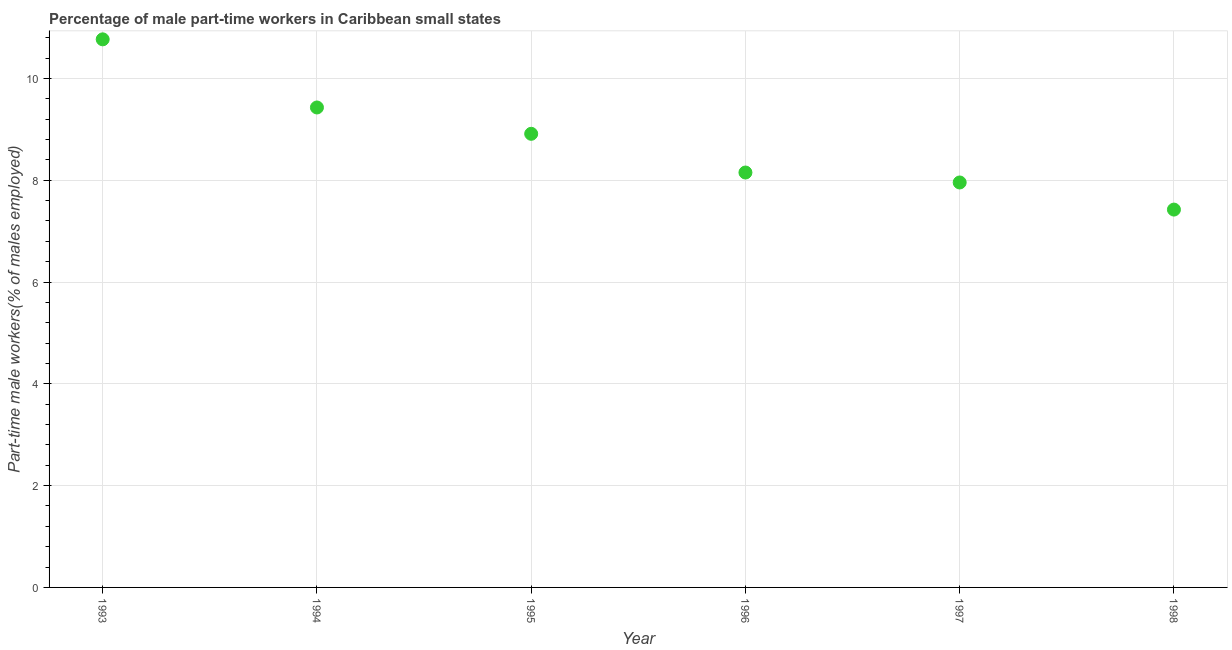What is the percentage of part-time male workers in 1996?
Ensure brevity in your answer.  8.15. Across all years, what is the maximum percentage of part-time male workers?
Keep it short and to the point. 10.77. Across all years, what is the minimum percentage of part-time male workers?
Your answer should be compact. 7.42. What is the sum of the percentage of part-time male workers?
Offer a terse response. 52.64. What is the difference between the percentage of part-time male workers in 1994 and 1996?
Give a very brief answer. 1.28. What is the average percentage of part-time male workers per year?
Your answer should be compact. 8.77. What is the median percentage of part-time male workers?
Keep it short and to the point. 8.53. Do a majority of the years between 1996 and 1993 (inclusive) have percentage of part-time male workers greater than 6 %?
Offer a terse response. Yes. What is the ratio of the percentage of part-time male workers in 1993 to that in 1998?
Offer a very short reply. 1.45. Is the percentage of part-time male workers in 1993 less than that in 1997?
Offer a terse response. No. What is the difference between the highest and the second highest percentage of part-time male workers?
Make the answer very short. 1.34. Is the sum of the percentage of part-time male workers in 1995 and 1998 greater than the maximum percentage of part-time male workers across all years?
Give a very brief answer. Yes. What is the difference between the highest and the lowest percentage of part-time male workers?
Make the answer very short. 3.34. How many dotlines are there?
Your response must be concise. 1. How many years are there in the graph?
Make the answer very short. 6. What is the difference between two consecutive major ticks on the Y-axis?
Give a very brief answer. 2. Are the values on the major ticks of Y-axis written in scientific E-notation?
Your answer should be very brief. No. Does the graph contain any zero values?
Your answer should be very brief. No. What is the title of the graph?
Ensure brevity in your answer.  Percentage of male part-time workers in Caribbean small states. What is the label or title of the Y-axis?
Your response must be concise. Part-time male workers(% of males employed). What is the Part-time male workers(% of males employed) in 1993?
Your answer should be very brief. 10.77. What is the Part-time male workers(% of males employed) in 1994?
Make the answer very short. 9.43. What is the Part-time male workers(% of males employed) in 1995?
Your response must be concise. 8.91. What is the Part-time male workers(% of males employed) in 1996?
Your response must be concise. 8.15. What is the Part-time male workers(% of males employed) in 1997?
Ensure brevity in your answer.  7.96. What is the Part-time male workers(% of males employed) in 1998?
Provide a short and direct response. 7.42. What is the difference between the Part-time male workers(% of males employed) in 1993 and 1994?
Your response must be concise. 1.34. What is the difference between the Part-time male workers(% of males employed) in 1993 and 1995?
Provide a succinct answer. 1.86. What is the difference between the Part-time male workers(% of males employed) in 1993 and 1996?
Offer a very short reply. 2.62. What is the difference between the Part-time male workers(% of males employed) in 1993 and 1997?
Your answer should be compact. 2.81. What is the difference between the Part-time male workers(% of males employed) in 1993 and 1998?
Offer a very short reply. 3.34. What is the difference between the Part-time male workers(% of males employed) in 1994 and 1995?
Provide a succinct answer. 0.52. What is the difference between the Part-time male workers(% of males employed) in 1994 and 1996?
Provide a succinct answer. 1.28. What is the difference between the Part-time male workers(% of males employed) in 1994 and 1997?
Offer a terse response. 1.47. What is the difference between the Part-time male workers(% of males employed) in 1994 and 1998?
Offer a terse response. 2.01. What is the difference between the Part-time male workers(% of males employed) in 1995 and 1996?
Give a very brief answer. 0.76. What is the difference between the Part-time male workers(% of males employed) in 1995 and 1997?
Offer a terse response. 0.96. What is the difference between the Part-time male workers(% of males employed) in 1995 and 1998?
Your answer should be compact. 1.49. What is the difference between the Part-time male workers(% of males employed) in 1996 and 1997?
Provide a succinct answer. 0.2. What is the difference between the Part-time male workers(% of males employed) in 1996 and 1998?
Ensure brevity in your answer.  0.73. What is the difference between the Part-time male workers(% of males employed) in 1997 and 1998?
Your answer should be compact. 0.53. What is the ratio of the Part-time male workers(% of males employed) in 1993 to that in 1994?
Provide a short and direct response. 1.14. What is the ratio of the Part-time male workers(% of males employed) in 1993 to that in 1995?
Give a very brief answer. 1.21. What is the ratio of the Part-time male workers(% of males employed) in 1993 to that in 1996?
Keep it short and to the point. 1.32. What is the ratio of the Part-time male workers(% of males employed) in 1993 to that in 1997?
Your response must be concise. 1.35. What is the ratio of the Part-time male workers(% of males employed) in 1993 to that in 1998?
Offer a very short reply. 1.45. What is the ratio of the Part-time male workers(% of males employed) in 1994 to that in 1995?
Your answer should be compact. 1.06. What is the ratio of the Part-time male workers(% of males employed) in 1994 to that in 1996?
Your answer should be very brief. 1.16. What is the ratio of the Part-time male workers(% of males employed) in 1994 to that in 1997?
Provide a short and direct response. 1.19. What is the ratio of the Part-time male workers(% of males employed) in 1994 to that in 1998?
Your response must be concise. 1.27. What is the ratio of the Part-time male workers(% of males employed) in 1995 to that in 1996?
Your answer should be compact. 1.09. What is the ratio of the Part-time male workers(% of males employed) in 1995 to that in 1997?
Offer a very short reply. 1.12. What is the ratio of the Part-time male workers(% of males employed) in 1995 to that in 1998?
Ensure brevity in your answer.  1.2. What is the ratio of the Part-time male workers(% of males employed) in 1996 to that in 1998?
Provide a succinct answer. 1.1. What is the ratio of the Part-time male workers(% of males employed) in 1997 to that in 1998?
Offer a very short reply. 1.07. 